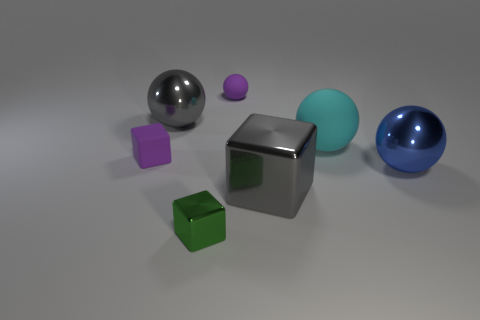Subtract all tiny cubes. How many cubes are left? 1 Add 2 cyan rubber spheres. How many objects exist? 9 Subtract all cyan spheres. How many spheres are left? 3 Subtract 1 blocks. How many blocks are left? 2 Subtract 0 green cylinders. How many objects are left? 7 Subtract all spheres. How many objects are left? 3 Subtract all green spheres. Subtract all yellow cylinders. How many spheres are left? 4 Subtract all large cyan rubber cubes. Subtract all gray things. How many objects are left? 5 Add 1 blue objects. How many blue objects are left? 2 Add 4 small green metal objects. How many small green metal objects exist? 5 